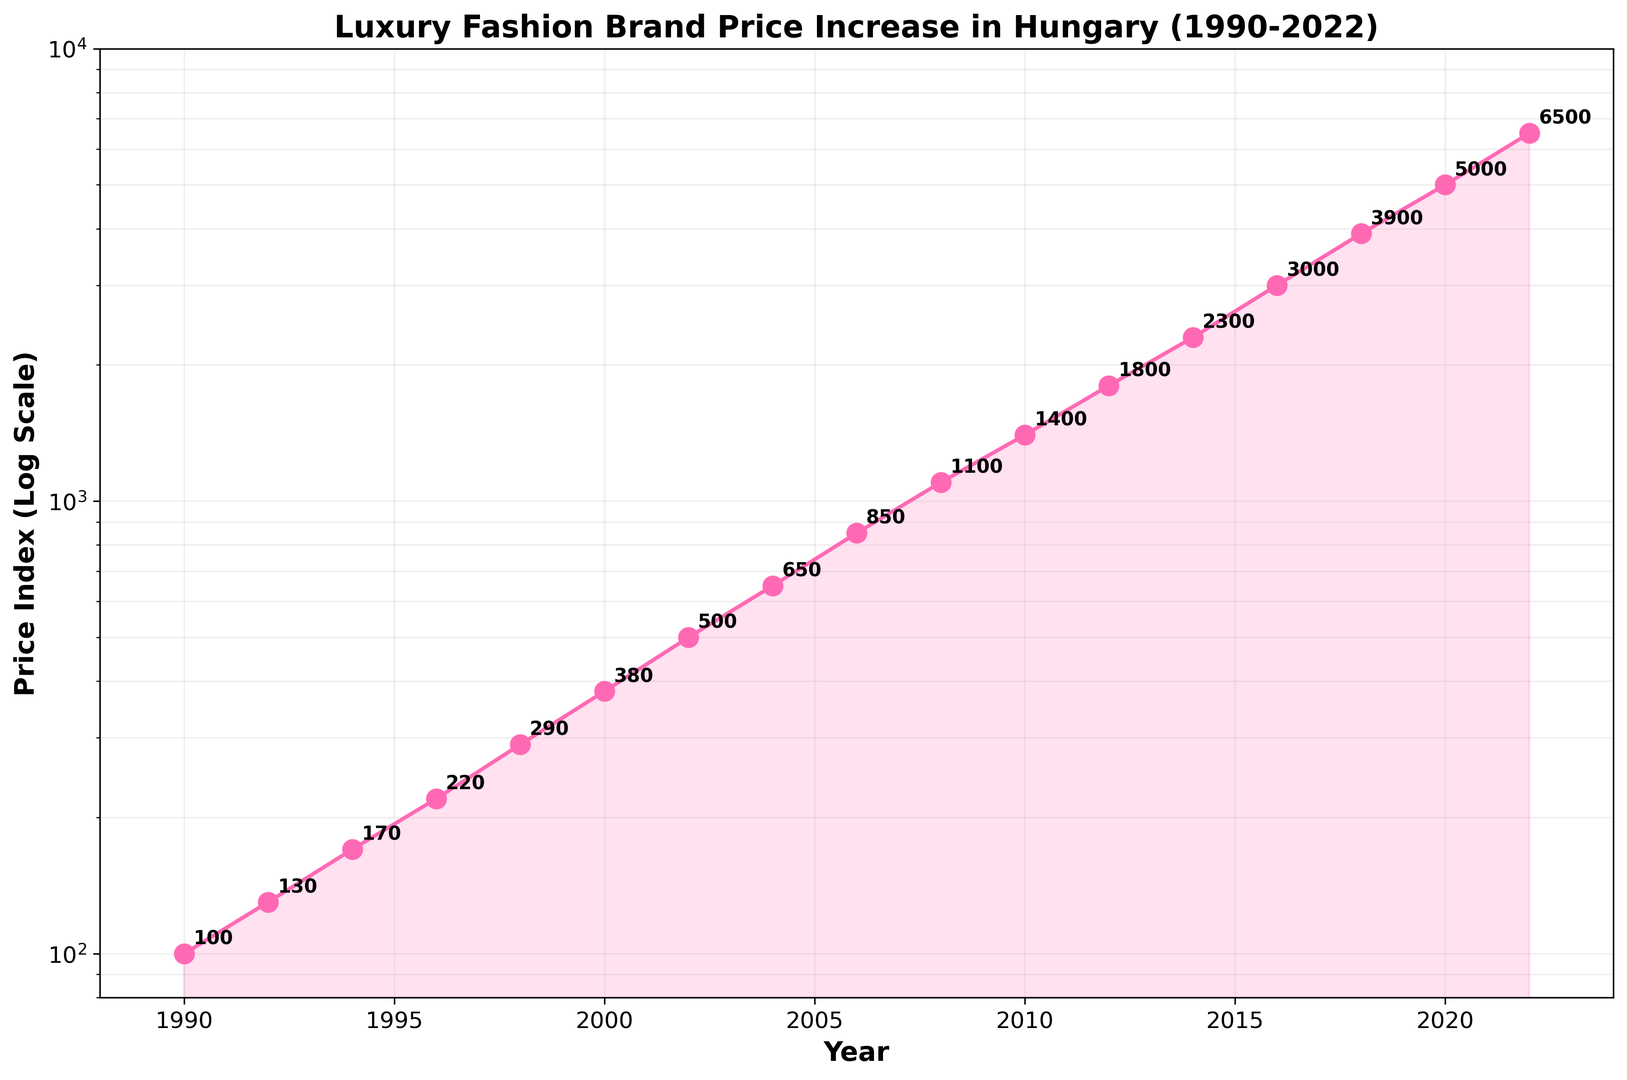What is the price index in the year 2000? In the graph, locate the data point on the x-axis corresponding to the year 2000, and then look up to find the y-axis value. The value at this point is the price index.
Answer: 380 Between which years did the price index more than quadruple? Identify points where the price index increased significantly by observing larger gaps on the log scale. Check specific years: from 1990 (100) to 2000 (380), it almost quadruples but not entirely. The largest jump more than quadrupling happens from 1990 (100) to 2006 (850), and also notably from 2008 (1100) to 2022 (6500).
Answer: 2008-2022 What is the average price index between 2006 and 2012? Find the price indexes for 2006 (850), 2008 (1100), 2010 (1400), and 2012 (1800). Their sum is 850 + 1100 + 1400 + 1800 = 5150. Now, divide by the number of years (4), which is 5150 / 4.
Answer: 1287.5 Which year shows the greatest price index according to the chart? Locate the highest point on the y-axis by following the plotted line upward and noting the corresponding year on the x-axis. The peak price index is in 2022, where the value reaches 6500.
Answer: 2022 How much did the price index increase between 1992 and 2006? Identify the price index in 1992 (130) and in 2006 (850). Subtract the former from the latter: 850 - 130.
Answer: 720 Which year has a price index closest to 5000? Locate the data points and observe where the price index comes closest to 5000 on the y-axis. The closest is the year 2020 with the price index exactly at 5000.
Answer: 2020 Which years show a price index greater than 1000? In the graph, follow the y-axis to the level above 1000 and note the corresponding years. The years are 2008 (1100), 2010 (1400), 2012 (1800), 2014 (2300), 2016 (3000), 2018 (3900), 2020 (5000), and 2022 (6500).
Answer: 2008, 2010, 2012, 2014, 2016, 2018, 2020, 2022 By what factor did the price index increase from 1996 to 2020? Identify the price indexes for 1996 (220) and 2020 (5000). Calculate the increase factor by dividing the latter by the former: 5000 / 220.
Answer: ~22.73 Identify the decade with the most rapid price index growth. Compare the slope of the graph lines visually over each decade. The most visually steep decade appears between 2012 (1800) to 2022 (6500).
Answer: 2012-2022 